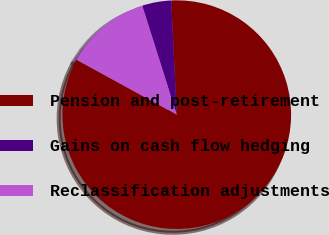<chart> <loc_0><loc_0><loc_500><loc_500><pie_chart><fcel>Pension and post-retirement<fcel>Gains on cash flow hedging<fcel>Reclassification adjustments<nl><fcel>83.75%<fcel>4.1%<fcel>12.15%<nl></chart> 